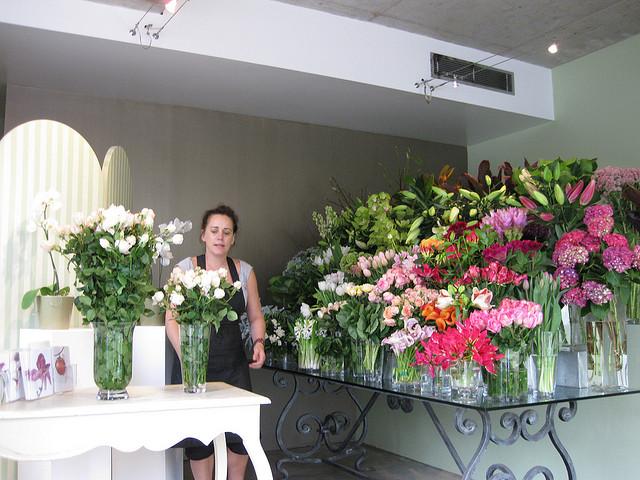What is the woman looking at?
Answer briefly. Flowers. Is the woman happy?
Give a very brief answer. No. What is on the glass table?
Short answer required. Flowers. 